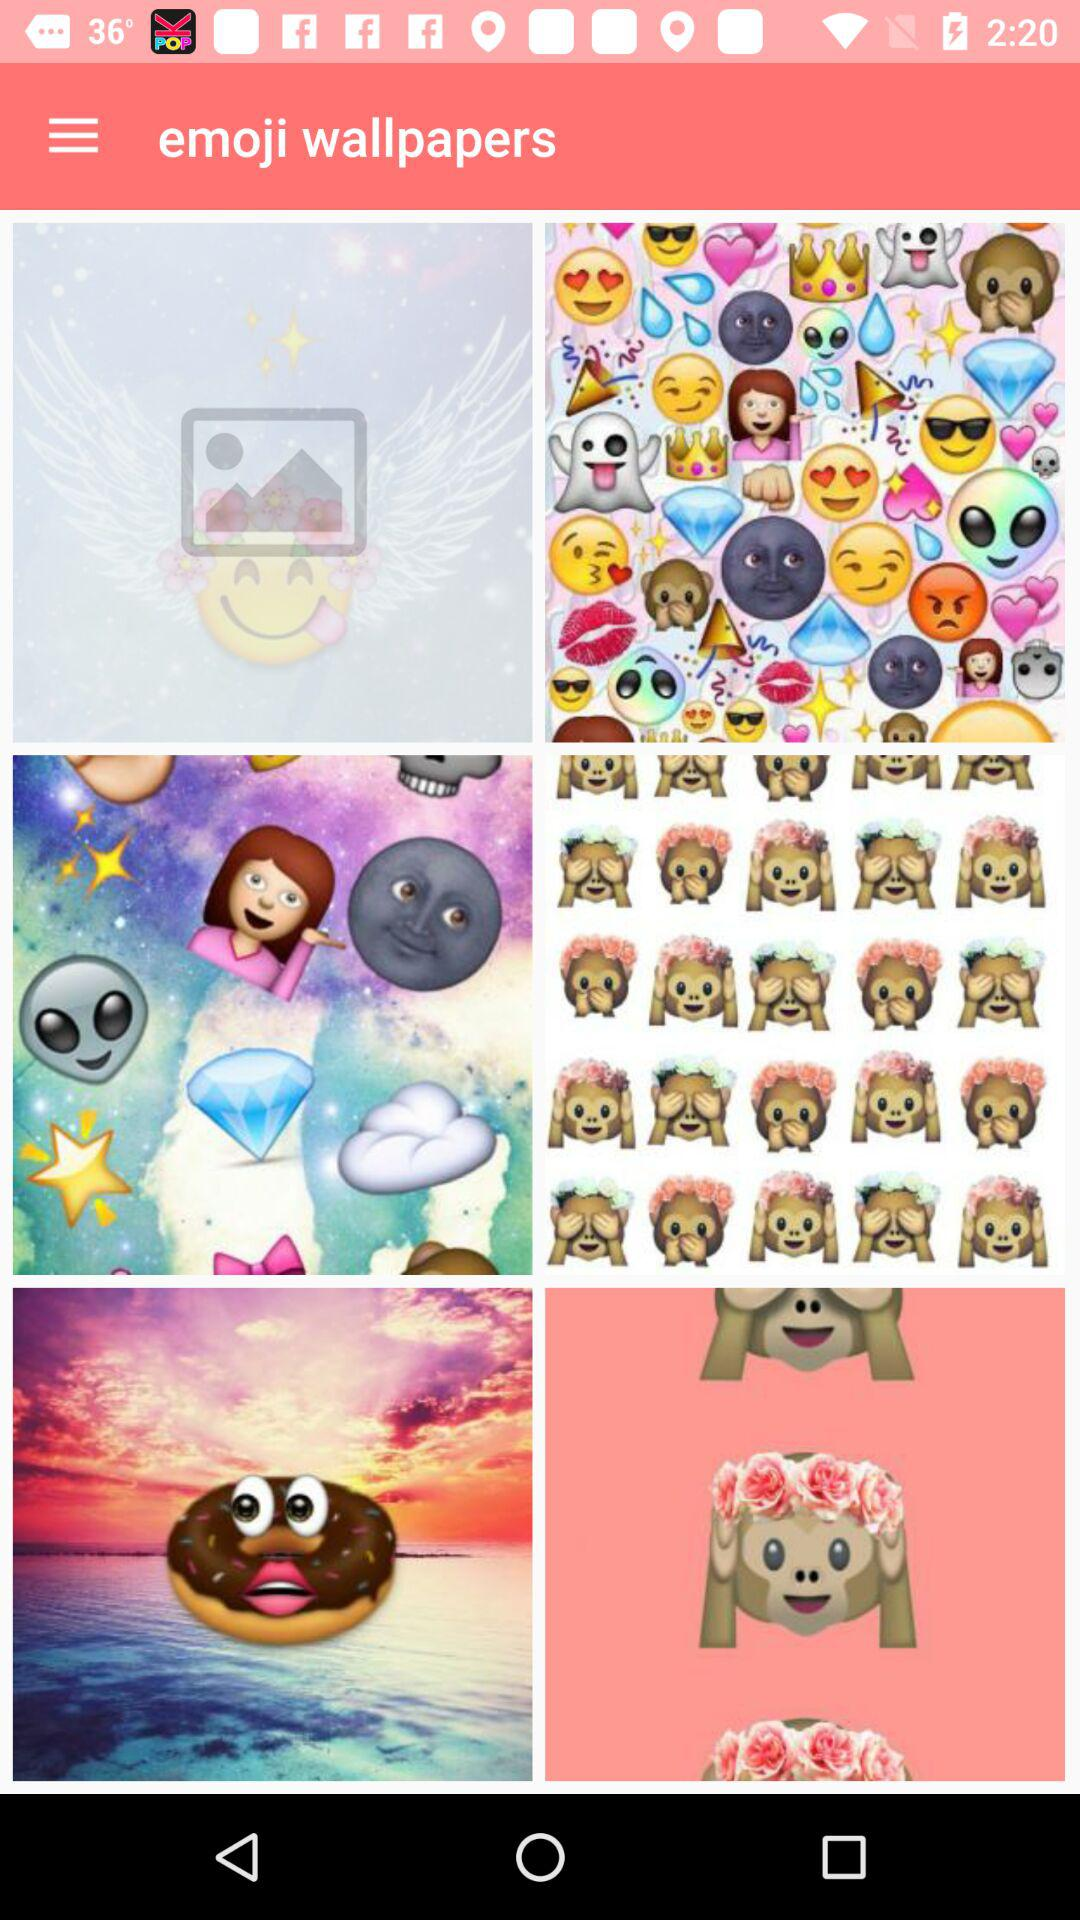What is the name of the application? The name of the application is "emoji wallpapers". 